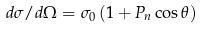<formula> <loc_0><loc_0><loc_500><loc_500>d \sigma / d \Omega = \sigma _ { 0 } \left ( 1 + P _ { n } \cos \theta \right )</formula> 